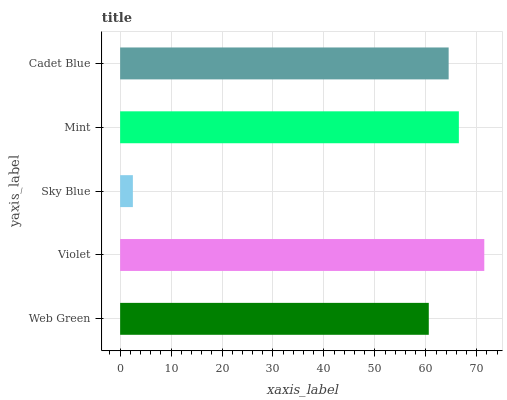Is Sky Blue the minimum?
Answer yes or no. Yes. Is Violet the maximum?
Answer yes or no. Yes. Is Violet the minimum?
Answer yes or no. No. Is Sky Blue the maximum?
Answer yes or no. No. Is Violet greater than Sky Blue?
Answer yes or no. Yes. Is Sky Blue less than Violet?
Answer yes or no. Yes. Is Sky Blue greater than Violet?
Answer yes or no. No. Is Violet less than Sky Blue?
Answer yes or no. No. Is Cadet Blue the high median?
Answer yes or no. Yes. Is Cadet Blue the low median?
Answer yes or no. Yes. Is Sky Blue the high median?
Answer yes or no. No. Is Mint the low median?
Answer yes or no. No. 